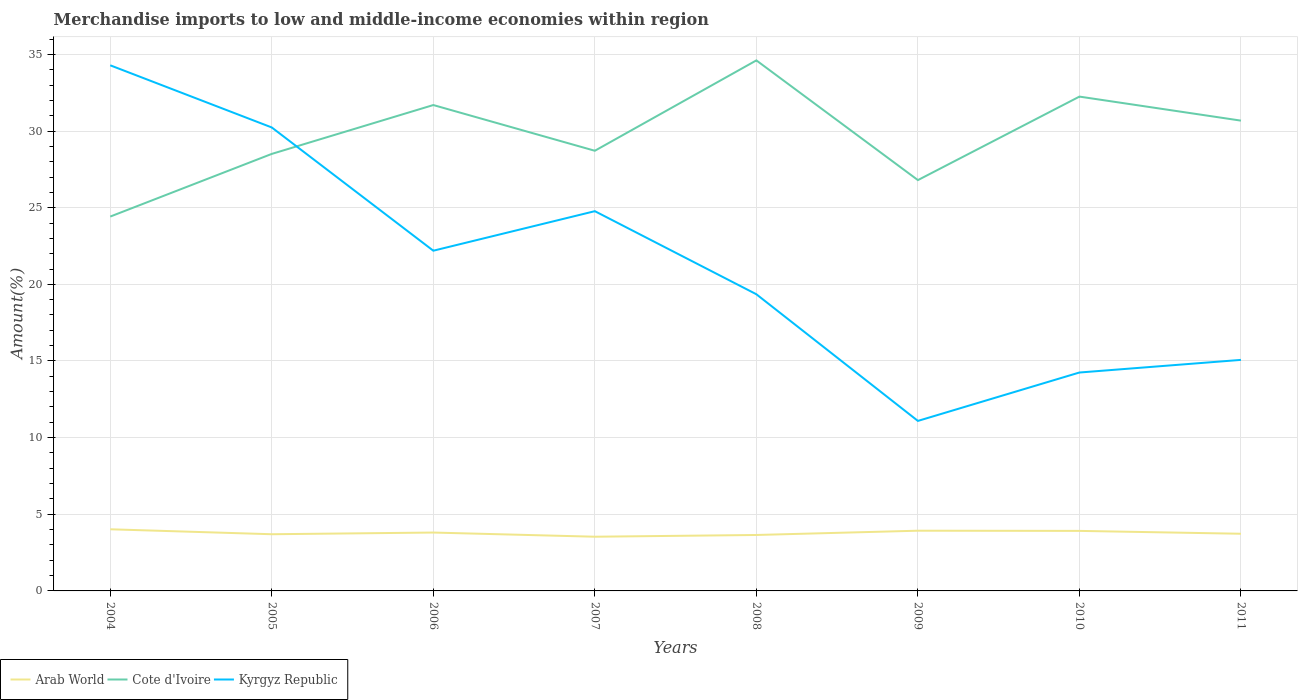Does the line corresponding to Cote d'Ivoire intersect with the line corresponding to Kyrgyz Republic?
Your answer should be very brief. Yes. Across all years, what is the maximum percentage of amount earned from merchandise imports in Arab World?
Provide a short and direct response. 3.54. In which year was the percentage of amount earned from merchandise imports in Arab World maximum?
Provide a succinct answer. 2007. What is the total percentage of amount earned from merchandise imports in Arab World in the graph?
Provide a succinct answer. 0.05. What is the difference between the highest and the second highest percentage of amount earned from merchandise imports in Arab World?
Make the answer very short. 0.49. What is the difference between the highest and the lowest percentage of amount earned from merchandise imports in Cote d'Ivoire?
Your answer should be very brief. 4. How many years are there in the graph?
Give a very brief answer. 8. What is the difference between two consecutive major ticks on the Y-axis?
Ensure brevity in your answer.  5. Are the values on the major ticks of Y-axis written in scientific E-notation?
Provide a succinct answer. No. Does the graph contain any zero values?
Make the answer very short. No. Where does the legend appear in the graph?
Your response must be concise. Bottom left. How many legend labels are there?
Provide a short and direct response. 3. How are the legend labels stacked?
Provide a succinct answer. Horizontal. What is the title of the graph?
Your response must be concise. Merchandise imports to low and middle-income economies within region. What is the label or title of the Y-axis?
Ensure brevity in your answer.  Amount(%). What is the Amount(%) of Arab World in 2004?
Provide a succinct answer. 4.02. What is the Amount(%) of Cote d'Ivoire in 2004?
Give a very brief answer. 24.42. What is the Amount(%) in Kyrgyz Republic in 2004?
Offer a terse response. 34.29. What is the Amount(%) of Arab World in 2005?
Make the answer very short. 3.7. What is the Amount(%) in Cote d'Ivoire in 2005?
Give a very brief answer. 28.51. What is the Amount(%) of Kyrgyz Republic in 2005?
Your response must be concise. 30.23. What is the Amount(%) in Arab World in 2006?
Your response must be concise. 3.81. What is the Amount(%) in Cote d'Ivoire in 2006?
Offer a very short reply. 31.7. What is the Amount(%) of Kyrgyz Republic in 2006?
Keep it short and to the point. 22.19. What is the Amount(%) of Arab World in 2007?
Offer a very short reply. 3.54. What is the Amount(%) of Cote d'Ivoire in 2007?
Your response must be concise. 28.71. What is the Amount(%) of Kyrgyz Republic in 2007?
Give a very brief answer. 24.77. What is the Amount(%) of Arab World in 2008?
Keep it short and to the point. 3.65. What is the Amount(%) of Cote d'Ivoire in 2008?
Keep it short and to the point. 34.61. What is the Amount(%) of Kyrgyz Republic in 2008?
Offer a terse response. 19.35. What is the Amount(%) of Arab World in 2009?
Offer a very short reply. 3.93. What is the Amount(%) of Cote d'Ivoire in 2009?
Offer a very short reply. 26.8. What is the Amount(%) in Kyrgyz Republic in 2009?
Ensure brevity in your answer.  11.09. What is the Amount(%) in Arab World in 2010?
Offer a terse response. 3.92. What is the Amount(%) in Cote d'Ivoire in 2010?
Keep it short and to the point. 32.25. What is the Amount(%) in Kyrgyz Republic in 2010?
Give a very brief answer. 14.25. What is the Amount(%) of Arab World in 2011?
Ensure brevity in your answer.  3.73. What is the Amount(%) of Cote d'Ivoire in 2011?
Provide a short and direct response. 30.68. What is the Amount(%) of Kyrgyz Republic in 2011?
Your answer should be compact. 15.07. Across all years, what is the maximum Amount(%) in Arab World?
Offer a very short reply. 4.02. Across all years, what is the maximum Amount(%) of Cote d'Ivoire?
Provide a succinct answer. 34.61. Across all years, what is the maximum Amount(%) of Kyrgyz Republic?
Offer a very short reply. 34.29. Across all years, what is the minimum Amount(%) in Arab World?
Make the answer very short. 3.54. Across all years, what is the minimum Amount(%) in Cote d'Ivoire?
Provide a short and direct response. 24.42. Across all years, what is the minimum Amount(%) in Kyrgyz Republic?
Offer a terse response. 11.09. What is the total Amount(%) of Arab World in the graph?
Your response must be concise. 30.29. What is the total Amount(%) of Cote d'Ivoire in the graph?
Offer a terse response. 237.68. What is the total Amount(%) of Kyrgyz Republic in the graph?
Offer a very short reply. 171.25. What is the difference between the Amount(%) of Arab World in 2004 and that in 2005?
Your answer should be very brief. 0.32. What is the difference between the Amount(%) in Cote d'Ivoire in 2004 and that in 2005?
Provide a succinct answer. -4.09. What is the difference between the Amount(%) in Kyrgyz Republic in 2004 and that in 2005?
Give a very brief answer. 4.05. What is the difference between the Amount(%) in Arab World in 2004 and that in 2006?
Provide a short and direct response. 0.21. What is the difference between the Amount(%) in Cote d'Ivoire in 2004 and that in 2006?
Provide a short and direct response. -7.28. What is the difference between the Amount(%) of Kyrgyz Republic in 2004 and that in 2006?
Your response must be concise. 12.09. What is the difference between the Amount(%) of Arab World in 2004 and that in 2007?
Ensure brevity in your answer.  0.49. What is the difference between the Amount(%) of Cote d'Ivoire in 2004 and that in 2007?
Offer a very short reply. -4.29. What is the difference between the Amount(%) of Kyrgyz Republic in 2004 and that in 2007?
Offer a terse response. 9.52. What is the difference between the Amount(%) in Arab World in 2004 and that in 2008?
Offer a terse response. 0.37. What is the difference between the Amount(%) of Cote d'Ivoire in 2004 and that in 2008?
Your answer should be very brief. -10.19. What is the difference between the Amount(%) in Kyrgyz Republic in 2004 and that in 2008?
Your answer should be compact. 14.94. What is the difference between the Amount(%) of Arab World in 2004 and that in 2009?
Provide a short and direct response. 0.09. What is the difference between the Amount(%) in Cote d'Ivoire in 2004 and that in 2009?
Offer a terse response. -2.38. What is the difference between the Amount(%) in Kyrgyz Republic in 2004 and that in 2009?
Give a very brief answer. 23.2. What is the difference between the Amount(%) in Arab World in 2004 and that in 2010?
Make the answer very short. 0.1. What is the difference between the Amount(%) in Cote d'Ivoire in 2004 and that in 2010?
Your response must be concise. -7.83. What is the difference between the Amount(%) in Kyrgyz Republic in 2004 and that in 2010?
Your response must be concise. 20.04. What is the difference between the Amount(%) of Arab World in 2004 and that in 2011?
Ensure brevity in your answer.  0.29. What is the difference between the Amount(%) of Cote d'Ivoire in 2004 and that in 2011?
Make the answer very short. -6.26. What is the difference between the Amount(%) in Kyrgyz Republic in 2004 and that in 2011?
Your answer should be compact. 19.22. What is the difference between the Amount(%) of Arab World in 2005 and that in 2006?
Offer a terse response. -0.11. What is the difference between the Amount(%) in Cote d'Ivoire in 2005 and that in 2006?
Your answer should be compact. -3.19. What is the difference between the Amount(%) of Kyrgyz Republic in 2005 and that in 2006?
Make the answer very short. 8.04. What is the difference between the Amount(%) in Arab World in 2005 and that in 2007?
Give a very brief answer. 0.16. What is the difference between the Amount(%) of Cote d'Ivoire in 2005 and that in 2007?
Give a very brief answer. -0.21. What is the difference between the Amount(%) of Kyrgyz Republic in 2005 and that in 2007?
Ensure brevity in your answer.  5.46. What is the difference between the Amount(%) in Arab World in 2005 and that in 2008?
Your response must be concise. 0.05. What is the difference between the Amount(%) of Cote d'Ivoire in 2005 and that in 2008?
Give a very brief answer. -6.1. What is the difference between the Amount(%) in Kyrgyz Republic in 2005 and that in 2008?
Offer a very short reply. 10.88. What is the difference between the Amount(%) of Arab World in 2005 and that in 2009?
Provide a short and direct response. -0.23. What is the difference between the Amount(%) in Cote d'Ivoire in 2005 and that in 2009?
Offer a terse response. 1.71. What is the difference between the Amount(%) in Kyrgyz Republic in 2005 and that in 2009?
Provide a short and direct response. 19.14. What is the difference between the Amount(%) in Arab World in 2005 and that in 2010?
Keep it short and to the point. -0.22. What is the difference between the Amount(%) of Cote d'Ivoire in 2005 and that in 2010?
Your response must be concise. -3.74. What is the difference between the Amount(%) in Kyrgyz Republic in 2005 and that in 2010?
Your answer should be very brief. 15.99. What is the difference between the Amount(%) in Arab World in 2005 and that in 2011?
Your answer should be compact. -0.03. What is the difference between the Amount(%) of Cote d'Ivoire in 2005 and that in 2011?
Offer a terse response. -2.17. What is the difference between the Amount(%) of Kyrgyz Republic in 2005 and that in 2011?
Your answer should be very brief. 15.16. What is the difference between the Amount(%) in Arab World in 2006 and that in 2007?
Provide a short and direct response. 0.27. What is the difference between the Amount(%) in Cote d'Ivoire in 2006 and that in 2007?
Your response must be concise. 2.98. What is the difference between the Amount(%) of Kyrgyz Republic in 2006 and that in 2007?
Offer a terse response. -2.58. What is the difference between the Amount(%) in Arab World in 2006 and that in 2008?
Your answer should be very brief. 0.16. What is the difference between the Amount(%) in Cote d'Ivoire in 2006 and that in 2008?
Keep it short and to the point. -2.91. What is the difference between the Amount(%) in Kyrgyz Republic in 2006 and that in 2008?
Offer a terse response. 2.84. What is the difference between the Amount(%) in Arab World in 2006 and that in 2009?
Give a very brief answer. -0.12. What is the difference between the Amount(%) in Cote d'Ivoire in 2006 and that in 2009?
Keep it short and to the point. 4.9. What is the difference between the Amount(%) of Kyrgyz Republic in 2006 and that in 2009?
Provide a succinct answer. 11.1. What is the difference between the Amount(%) of Arab World in 2006 and that in 2010?
Your response must be concise. -0.11. What is the difference between the Amount(%) of Cote d'Ivoire in 2006 and that in 2010?
Offer a terse response. -0.55. What is the difference between the Amount(%) in Kyrgyz Republic in 2006 and that in 2010?
Your answer should be very brief. 7.95. What is the difference between the Amount(%) of Arab World in 2006 and that in 2011?
Provide a short and direct response. 0.08. What is the difference between the Amount(%) in Cote d'Ivoire in 2006 and that in 2011?
Make the answer very short. 1.02. What is the difference between the Amount(%) of Kyrgyz Republic in 2006 and that in 2011?
Offer a terse response. 7.12. What is the difference between the Amount(%) of Arab World in 2007 and that in 2008?
Give a very brief answer. -0.11. What is the difference between the Amount(%) of Cote d'Ivoire in 2007 and that in 2008?
Offer a very short reply. -5.89. What is the difference between the Amount(%) of Kyrgyz Republic in 2007 and that in 2008?
Provide a short and direct response. 5.42. What is the difference between the Amount(%) of Arab World in 2007 and that in 2009?
Give a very brief answer. -0.39. What is the difference between the Amount(%) of Cote d'Ivoire in 2007 and that in 2009?
Your answer should be compact. 1.91. What is the difference between the Amount(%) in Kyrgyz Republic in 2007 and that in 2009?
Offer a terse response. 13.68. What is the difference between the Amount(%) in Arab World in 2007 and that in 2010?
Your answer should be very brief. -0.38. What is the difference between the Amount(%) of Cote d'Ivoire in 2007 and that in 2010?
Make the answer very short. -3.53. What is the difference between the Amount(%) in Kyrgyz Republic in 2007 and that in 2010?
Your answer should be very brief. 10.53. What is the difference between the Amount(%) of Arab World in 2007 and that in 2011?
Keep it short and to the point. -0.19. What is the difference between the Amount(%) of Cote d'Ivoire in 2007 and that in 2011?
Provide a short and direct response. -1.97. What is the difference between the Amount(%) in Kyrgyz Republic in 2007 and that in 2011?
Your answer should be compact. 9.7. What is the difference between the Amount(%) in Arab World in 2008 and that in 2009?
Your response must be concise. -0.28. What is the difference between the Amount(%) of Cote d'Ivoire in 2008 and that in 2009?
Provide a short and direct response. 7.81. What is the difference between the Amount(%) of Kyrgyz Republic in 2008 and that in 2009?
Keep it short and to the point. 8.26. What is the difference between the Amount(%) of Arab World in 2008 and that in 2010?
Ensure brevity in your answer.  -0.27. What is the difference between the Amount(%) in Cote d'Ivoire in 2008 and that in 2010?
Give a very brief answer. 2.36. What is the difference between the Amount(%) in Kyrgyz Republic in 2008 and that in 2010?
Keep it short and to the point. 5.11. What is the difference between the Amount(%) in Arab World in 2008 and that in 2011?
Your answer should be very brief. -0.08. What is the difference between the Amount(%) of Cote d'Ivoire in 2008 and that in 2011?
Ensure brevity in your answer.  3.93. What is the difference between the Amount(%) in Kyrgyz Republic in 2008 and that in 2011?
Provide a short and direct response. 4.28. What is the difference between the Amount(%) of Arab World in 2009 and that in 2010?
Keep it short and to the point. 0.01. What is the difference between the Amount(%) of Cote d'Ivoire in 2009 and that in 2010?
Give a very brief answer. -5.45. What is the difference between the Amount(%) in Kyrgyz Republic in 2009 and that in 2010?
Your response must be concise. -3.16. What is the difference between the Amount(%) of Arab World in 2009 and that in 2011?
Ensure brevity in your answer.  0.2. What is the difference between the Amount(%) of Cote d'Ivoire in 2009 and that in 2011?
Ensure brevity in your answer.  -3.88. What is the difference between the Amount(%) in Kyrgyz Republic in 2009 and that in 2011?
Provide a succinct answer. -3.98. What is the difference between the Amount(%) of Arab World in 2010 and that in 2011?
Your response must be concise. 0.19. What is the difference between the Amount(%) of Cote d'Ivoire in 2010 and that in 2011?
Keep it short and to the point. 1.57. What is the difference between the Amount(%) of Kyrgyz Republic in 2010 and that in 2011?
Provide a short and direct response. -0.82. What is the difference between the Amount(%) in Arab World in 2004 and the Amount(%) in Cote d'Ivoire in 2005?
Offer a terse response. -24.49. What is the difference between the Amount(%) in Arab World in 2004 and the Amount(%) in Kyrgyz Republic in 2005?
Your response must be concise. -26.21. What is the difference between the Amount(%) of Cote d'Ivoire in 2004 and the Amount(%) of Kyrgyz Republic in 2005?
Provide a succinct answer. -5.81. What is the difference between the Amount(%) of Arab World in 2004 and the Amount(%) of Cote d'Ivoire in 2006?
Provide a succinct answer. -27.68. What is the difference between the Amount(%) of Arab World in 2004 and the Amount(%) of Kyrgyz Republic in 2006?
Your answer should be very brief. -18.17. What is the difference between the Amount(%) of Cote d'Ivoire in 2004 and the Amount(%) of Kyrgyz Republic in 2006?
Make the answer very short. 2.23. What is the difference between the Amount(%) in Arab World in 2004 and the Amount(%) in Cote d'Ivoire in 2007?
Give a very brief answer. -24.69. What is the difference between the Amount(%) in Arab World in 2004 and the Amount(%) in Kyrgyz Republic in 2007?
Give a very brief answer. -20.75. What is the difference between the Amount(%) in Cote d'Ivoire in 2004 and the Amount(%) in Kyrgyz Republic in 2007?
Keep it short and to the point. -0.35. What is the difference between the Amount(%) of Arab World in 2004 and the Amount(%) of Cote d'Ivoire in 2008?
Keep it short and to the point. -30.59. What is the difference between the Amount(%) of Arab World in 2004 and the Amount(%) of Kyrgyz Republic in 2008?
Your answer should be very brief. -15.33. What is the difference between the Amount(%) of Cote d'Ivoire in 2004 and the Amount(%) of Kyrgyz Republic in 2008?
Offer a terse response. 5.07. What is the difference between the Amount(%) of Arab World in 2004 and the Amount(%) of Cote d'Ivoire in 2009?
Ensure brevity in your answer.  -22.78. What is the difference between the Amount(%) in Arab World in 2004 and the Amount(%) in Kyrgyz Republic in 2009?
Provide a succinct answer. -7.07. What is the difference between the Amount(%) of Cote d'Ivoire in 2004 and the Amount(%) of Kyrgyz Republic in 2009?
Offer a terse response. 13.33. What is the difference between the Amount(%) of Arab World in 2004 and the Amount(%) of Cote d'Ivoire in 2010?
Offer a terse response. -28.23. What is the difference between the Amount(%) of Arab World in 2004 and the Amount(%) of Kyrgyz Republic in 2010?
Offer a very short reply. -10.23. What is the difference between the Amount(%) of Cote d'Ivoire in 2004 and the Amount(%) of Kyrgyz Republic in 2010?
Offer a very short reply. 10.17. What is the difference between the Amount(%) of Arab World in 2004 and the Amount(%) of Cote d'Ivoire in 2011?
Your response must be concise. -26.66. What is the difference between the Amount(%) in Arab World in 2004 and the Amount(%) in Kyrgyz Republic in 2011?
Offer a terse response. -11.05. What is the difference between the Amount(%) in Cote d'Ivoire in 2004 and the Amount(%) in Kyrgyz Republic in 2011?
Provide a succinct answer. 9.35. What is the difference between the Amount(%) of Arab World in 2005 and the Amount(%) of Cote d'Ivoire in 2006?
Your answer should be very brief. -28. What is the difference between the Amount(%) of Arab World in 2005 and the Amount(%) of Kyrgyz Republic in 2006?
Provide a succinct answer. -18.5. What is the difference between the Amount(%) in Cote d'Ivoire in 2005 and the Amount(%) in Kyrgyz Republic in 2006?
Provide a succinct answer. 6.31. What is the difference between the Amount(%) in Arab World in 2005 and the Amount(%) in Cote d'Ivoire in 2007?
Offer a very short reply. -25.02. What is the difference between the Amount(%) of Arab World in 2005 and the Amount(%) of Kyrgyz Republic in 2007?
Give a very brief answer. -21.08. What is the difference between the Amount(%) in Cote d'Ivoire in 2005 and the Amount(%) in Kyrgyz Republic in 2007?
Keep it short and to the point. 3.74. What is the difference between the Amount(%) of Arab World in 2005 and the Amount(%) of Cote d'Ivoire in 2008?
Offer a very short reply. -30.91. What is the difference between the Amount(%) of Arab World in 2005 and the Amount(%) of Kyrgyz Republic in 2008?
Offer a very short reply. -15.66. What is the difference between the Amount(%) of Cote d'Ivoire in 2005 and the Amount(%) of Kyrgyz Republic in 2008?
Provide a succinct answer. 9.16. What is the difference between the Amount(%) in Arab World in 2005 and the Amount(%) in Cote d'Ivoire in 2009?
Make the answer very short. -23.1. What is the difference between the Amount(%) in Arab World in 2005 and the Amount(%) in Kyrgyz Republic in 2009?
Offer a very short reply. -7.39. What is the difference between the Amount(%) of Cote d'Ivoire in 2005 and the Amount(%) of Kyrgyz Republic in 2009?
Ensure brevity in your answer.  17.42. What is the difference between the Amount(%) in Arab World in 2005 and the Amount(%) in Cote d'Ivoire in 2010?
Offer a terse response. -28.55. What is the difference between the Amount(%) in Arab World in 2005 and the Amount(%) in Kyrgyz Republic in 2010?
Offer a very short reply. -10.55. What is the difference between the Amount(%) in Cote d'Ivoire in 2005 and the Amount(%) in Kyrgyz Republic in 2010?
Give a very brief answer. 14.26. What is the difference between the Amount(%) of Arab World in 2005 and the Amount(%) of Cote d'Ivoire in 2011?
Your answer should be very brief. -26.98. What is the difference between the Amount(%) in Arab World in 2005 and the Amount(%) in Kyrgyz Republic in 2011?
Keep it short and to the point. -11.37. What is the difference between the Amount(%) in Cote d'Ivoire in 2005 and the Amount(%) in Kyrgyz Republic in 2011?
Give a very brief answer. 13.44. What is the difference between the Amount(%) of Arab World in 2006 and the Amount(%) of Cote d'Ivoire in 2007?
Offer a very short reply. -24.91. What is the difference between the Amount(%) in Arab World in 2006 and the Amount(%) in Kyrgyz Republic in 2007?
Your answer should be very brief. -20.97. What is the difference between the Amount(%) in Cote d'Ivoire in 2006 and the Amount(%) in Kyrgyz Republic in 2007?
Ensure brevity in your answer.  6.92. What is the difference between the Amount(%) in Arab World in 2006 and the Amount(%) in Cote d'Ivoire in 2008?
Your answer should be compact. -30.8. What is the difference between the Amount(%) of Arab World in 2006 and the Amount(%) of Kyrgyz Republic in 2008?
Your response must be concise. -15.55. What is the difference between the Amount(%) of Cote d'Ivoire in 2006 and the Amount(%) of Kyrgyz Republic in 2008?
Your answer should be very brief. 12.34. What is the difference between the Amount(%) of Arab World in 2006 and the Amount(%) of Cote d'Ivoire in 2009?
Offer a very short reply. -22.99. What is the difference between the Amount(%) of Arab World in 2006 and the Amount(%) of Kyrgyz Republic in 2009?
Offer a very short reply. -7.28. What is the difference between the Amount(%) in Cote d'Ivoire in 2006 and the Amount(%) in Kyrgyz Republic in 2009?
Your answer should be compact. 20.61. What is the difference between the Amount(%) of Arab World in 2006 and the Amount(%) of Cote d'Ivoire in 2010?
Provide a succinct answer. -28.44. What is the difference between the Amount(%) of Arab World in 2006 and the Amount(%) of Kyrgyz Republic in 2010?
Offer a very short reply. -10.44. What is the difference between the Amount(%) of Cote d'Ivoire in 2006 and the Amount(%) of Kyrgyz Republic in 2010?
Offer a very short reply. 17.45. What is the difference between the Amount(%) of Arab World in 2006 and the Amount(%) of Cote d'Ivoire in 2011?
Offer a very short reply. -26.87. What is the difference between the Amount(%) of Arab World in 2006 and the Amount(%) of Kyrgyz Republic in 2011?
Your answer should be very brief. -11.26. What is the difference between the Amount(%) in Cote d'Ivoire in 2006 and the Amount(%) in Kyrgyz Republic in 2011?
Ensure brevity in your answer.  16.62. What is the difference between the Amount(%) of Arab World in 2007 and the Amount(%) of Cote d'Ivoire in 2008?
Offer a terse response. -31.07. What is the difference between the Amount(%) of Arab World in 2007 and the Amount(%) of Kyrgyz Republic in 2008?
Your answer should be compact. -15.82. What is the difference between the Amount(%) in Cote d'Ivoire in 2007 and the Amount(%) in Kyrgyz Republic in 2008?
Keep it short and to the point. 9.36. What is the difference between the Amount(%) of Arab World in 2007 and the Amount(%) of Cote d'Ivoire in 2009?
Ensure brevity in your answer.  -23.26. What is the difference between the Amount(%) of Arab World in 2007 and the Amount(%) of Kyrgyz Republic in 2009?
Provide a short and direct response. -7.55. What is the difference between the Amount(%) of Cote d'Ivoire in 2007 and the Amount(%) of Kyrgyz Republic in 2009?
Give a very brief answer. 17.62. What is the difference between the Amount(%) in Arab World in 2007 and the Amount(%) in Cote d'Ivoire in 2010?
Provide a short and direct response. -28.71. What is the difference between the Amount(%) of Arab World in 2007 and the Amount(%) of Kyrgyz Republic in 2010?
Ensure brevity in your answer.  -10.71. What is the difference between the Amount(%) of Cote d'Ivoire in 2007 and the Amount(%) of Kyrgyz Republic in 2010?
Ensure brevity in your answer.  14.47. What is the difference between the Amount(%) of Arab World in 2007 and the Amount(%) of Cote d'Ivoire in 2011?
Your answer should be very brief. -27.14. What is the difference between the Amount(%) of Arab World in 2007 and the Amount(%) of Kyrgyz Republic in 2011?
Offer a terse response. -11.54. What is the difference between the Amount(%) of Cote d'Ivoire in 2007 and the Amount(%) of Kyrgyz Republic in 2011?
Your answer should be compact. 13.64. What is the difference between the Amount(%) in Arab World in 2008 and the Amount(%) in Cote d'Ivoire in 2009?
Make the answer very short. -23.15. What is the difference between the Amount(%) of Arab World in 2008 and the Amount(%) of Kyrgyz Republic in 2009?
Your answer should be compact. -7.44. What is the difference between the Amount(%) in Cote d'Ivoire in 2008 and the Amount(%) in Kyrgyz Republic in 2009?
Give a very brief answer. 23.52. What is the difference between the Amount(%) in Arab World in 2008 and the Amount(%) in Cote d'Ivoire in 2010?
Provide a short and direct response. -28.6. What is the difference between the Amount(%) of Arab World in 2008 and the Amount(%) of Kyrgyz Republic in 2010?
Provide a short and direct response. -10.6. What is the difference between the Amount(%) of Cote d'Ivoire in 2008 and the Amount(%) of Kyrgyz Republic in 2010?
Your response must be concise. 20.36. What is the difference between the Amount(%) of Arab World in 2008 and the Amount(%) of Cote d'Ivoire in 2011?
Offer a very short reply. -27.03. What is the difference between the Amount(%) of Arab World in 2008 and the Amount(%) of Kyrgyz Republic in 2011?
Your answer should be compact. -11.42. What is the difference between the Amount(%) of Cote d'Ivoire in 2008 and the Amount(%) of Kyrgyz Republic in 2011?
Offer a very short reply. 19.54. What is the difference between the Amount(%) in Arab World in 2009 and the Amount(%) in Cote d'Ivoire in 2010?
Your response must be concise. -28.32. What is the difference between the Amount(%) of Arab World in 2009 and the Amount(%) of Kyrgyz Republic in 2010?
Ensure brevity in your answer.  -10.32. What is the difference between the Amount(%) in Cote d'Ivoire in 2009 and the Amount(%) in Kyrgyz Republic in 2010?
Your response must be concise. 12.55. What is the difference between the Amount(%) of Arab World in 2009 and the Amount(%) of Cote d'Ivoire in 2011?
Ensure brevity in your answer.  -26.75. What is the difference between the Amount(%) of Arab World in 2009 and the Amount(%) of Kyrgyz Republic in 2011?
Offer a terse response. -11.14. What is the difference between the Amount(%) in Cote d'Ivoire in 2009 and the Amount(%) in Kyrgyz Republic in 2011?
Make the answer very short. 11.73. What is the difference between the Amount(%) of Arab World in 2010 and the Amount(%) of Cote d'Ivoire in 2011?
Provide a short and direct response. -26.76. What is the difference between the Amount(%) in Arab World in 2010 and the Amount(%) in Kyrgyz Republic in 2011?
Ensure brevity in your answer.  -11.16. What is the difference between the Amount(%) in Cote d'Ivoire in 2010 and the Amount(%) in Kyrgyz Republic in 2011?
Give a very brief answer. 17.18. What is the average Amount(%) in Arab World per year?
Keep it short and to the point. 3.79. What is the average Amount(%) of Cote d'Ivoire per year?
Offer a terse response. 29.71. What is the average Amount(%) in Kyrgyz Republic per year?
Provide a succinct answer. 21.41. In the year 2004, what is the difference between the Amount(%) in Arab World and Amount(%) in Cote d'Ivoire?
Your answer should be very brief. -20.4. In the year 2004, what is the difference between the Amount(%) of Arab World and Amount(%) of Kyrgyz Republic?
Offer a very short reply. -30.27. In the year 2004, what is the difference between the Amount(%) in Cote d'Ivoire and Amount(%) in Kyrgyz Republic?
Offer a terse response. -9.87. In the year 2005, what is the difference between the Amount(%) of Arab World and Amount(%) of Cote d'Ivoire?
Make the answer very short. -24.81. In the year 2005, what is the difference between the Amount(%) in Arab World and Amount(%) in Kyrgyz Republic?
Your answer should be very brief. -26.54. In the year 2005, what is the difference between the Amount(%) of Cote d'Ivoire and Amount(%) of Kyrgyz Republic?
Provide a succinct answer. -1.72. In the year 2006, what is the difference between the Amount(%) in Arab World and Amount(%) in Cote d'Ivoire?
Make the answer very short. -27.89. In the year 2006, what is the difference between the Amount(%) in Arab World and Amount(%) in Kyrgyz Republic?
Your response must be concise. -18.39. In the year 2006, what is the difference between the Amount(%) of Cote d'Ivoire and Amount(%) of Kyrgyz Republic?
Provide a succinct answer. 9.5. In the year 2007, what is the difference between the Amount(%) of Arab World and Amount(%) of Cote d'Ivoire?
Provide a short and direct response. -25.18. In the year 2007, what is the difference between the Amount(%) of Arab World and Amount(%) of Kyrgyz Republic?
Make the answer very short. -21.24. In the year 2007, what is the difference between the Amount(%) in Cote d'Ivoire and Amount(%) in Kyrgyz Republic?
Offer a very short reply. 3.94. In the year 2008, what is the difference between the Amount(%) in Arab World and Amount(%) in Cote d'Ivoire?
Ensure brevity in your answer.  -30.96. In the year 2008, what is the difference between the Amount(%) of Arab World and Amount(%) of Kyrgyz Republic?
Make the answer very short. -15.7. In the year 2008, what is the difference between the Amount(%) in Cote d'Ivoire and Amount(%) in Kyrgyz Republic?
Your answer should be compact. 15.26. In the year 2009, what is the difference between the Amount(%) in Arab World and Amount(%) in Cote d'Ivoire?
Your answer should be very brief. -22.87. In the year 2009, what is the difference between the Amount(%) of Arab World and Amount(%) of Kyrgyz Republic?
Ensure brevity in your answer.  -7.16. In the year 2009, what is the difference between the Amount(%) of Cote d'Ivoire and Amount(%) of Kyrgyz Republic?
Provide a short and direct response. 15.71. In the year 2010, what is the difference between the Amount(%) in Arab World and Amount(%) in Cote d'Ivoire?
Provide a short and direct response. -28.33. In the year 2010, what is the difference between the Amount(%) in Arab World and Amount(%) in Kyrgyz Republic?
Give a very brief answer. -10.33. In the year 2010, what is the difference between the Amount(%) in Cote d'Ivoire and Amount(%) in Kyrgyz Republic?
Give a very brief answer. 18. In the year 2011, what is the difference between the Amount(%) of Arab World and Amount(%) of Cote d'Ivoire?
Make the answer very short. -26.95. In the year 2011, what is the difference between the Amount(%) in Arab World and Amount(%) in Kyrgyz Republic?
Provide a succinct answer. -11.34. In the year 2011, what is the difference between the Amount(%) in Cote d'Ivoire and Amount(%) in Kyrgyz Republic?
Provide a succinct answer. 15.61. What is the ratio of the Amount(%) of Arab World in 2004 to that in 2005?
Offer a very short reply. 1.09. What is the ratio of the Amount(%) in Cote d'Ivoire in 2004 to that in 2005?
Ensure brevity in your answer.  0.86. What is the ratio of the Amount(%) of Kyrgyz Republic in 2004 to that in 2005?
Make the answer very short. 1.13. What is the ratio of the Amount(%) in Arab World in 2004 to that in 2006?
Ensure brevity in your answer.  1.06. What is the ratio of the Amount(%) in Cote d'Ivoire in 2004 to that in 2006?
Provide a succinct answer. 0.77. What is the ratio of the Amount(%) in Kyrgyz Republic in 2004 to that in 2006?
Your answer should be very brief. 1.54. What is the ratio of the Amount(%) of Arab World in 2004 to that in 2007?
Your answer should be compact. 1.14. What is the ratio of the Amount(%) in Cote d'Ivoire in 2004 to that in 2007?
Provide a succinct answer. 0.85. What is the ratio of the Amount(%) of Kyrgyz Republic in 2004 to that in 2007?
Provide a short and direct response. 1.38. What is the ratio of the Amount(%) of Arab World in 2004 to that in 2008?
Your response must be concise. 1.1. What is the ratio of the Amount(%) in Cote d'Ivoire in 2004 to that in 2008?
Offer a very short reply. 0.71. What is the ratio of the Amount(%) of Kyrgyz Republic in 2004 to that in 2008?
Ensure brevity in your answer.  1.77. What is the ratio of the Amount(%) in Arab World in 2004 to that in 2009?
Make the answer very short. 1.02. What is the ratio of the Amount(%) of Cote d'Ivoire in 2004 to that in 2009?
Give a very brief answer. 0.91. What is the ratio of the Amount(%) of Kyrgyz Republic in 2004 to that in 2009?
Ensure brevity in your answer.  3.09. What is the ratio of the Amount(%) in Arab World in 2004 to that in 2010?
Keep it short and to the point. 1.03. What is the ratio of the Amount(%) in Cote d'Ivoire in 2004 to that in 2010?
Make the answer very short. 0.76. What is the ratio of the Amount(%) of Kyrgyz Republic in 2004 to that in 2010?
Provide a short and direct response. 2.41. What is the ratio of the Amount(%) in Arab World in 2004 to that in 2011?
Make the answer very short. 1.08. What is the ratio of the Amount(%) in Cote d'Ivoire in 2004 to that in 2011?
Provide a succinct answer. 0.8. What is the ratio of the Amount(%) of Kyrgyz Republic in 2004 to that in 2011?
Provide a short and direct response. 2.27. What is the ratio of the Amount(%) in Arab World in 2005 to that in 2006?
Make the answer very short. 0.97. What is the ratio of the Amount(%) in Cote d'Ivoire in 2005 to that in 2006?
Provide a short and direct response. 0.9. What is the ratio of the Amount(%) of Kyrgyz Republic in 2005 to that in 2006?
Offer a terse response. 1.36. What is the ratio of the Amount(%) of Arab World in 2005 to that in 2007?
Make the answer very short. 1.05. What is the ratio of the Amount(%) in Kyrgyz Republic in 2005 to that in 2007?
Your response must be concise. 1.22. What is the ratio of the Amount(%) of Arab World in 2005 to that in 2008?
Ensure brevity in your answer.  1.01. What is the ratio of the Amount(%) of Cote d'Ivoire in 2005 to that in 2008?
Make the answer very short. 0.82. What is the ratio of the Amount(%) in Kyrgyz Republic in 2005 to that in 2008?
Offer a terse response. 1.56. What is the ratio of the Amount(%) in Arab World in 2005 to that in 2009?
Give a very brief answer. 0.94. What is the ratio of the Amount(%) in Cote d'Ivoire in 2005 to that in 2009?
Provide a short and direct response. 1.06. What is the ratio of the Amount(%) in Kyrgyz Republic in 2005 to that in 2009?
Ensure brevity in your answer.  2.73. What is the ratio of the Amount(%) of Arab World in 2005 to that in 2010?
Your answer should be compact. 0.94. What is the ratio of the Amount(%) of Cote d'Ivoire in 2005 to that in 2010?
Keep it short and to the point. 0.88. What is the ratio of the Amount(%) of Kyrgyz Republic in 2005 to that in 2010?
Your response must be concise. 2.12. What is the ratio of the Amount(%) of Arab World in 2005 to that in 2011?
Provide a short and direct response. 0.99. What is the ratio of the Amount(%) of Cote d'Ivoire in 2005 to that in 2011?
Provide a short and direct response. 0.93. What is the ratio of the Amount(%) in Kyrgyz Republic in 2005 to that in 2011?
Your answer should be very brief. 2.01. What is the ratio of the Amount(%) of Arab World in 2006 to that in 2007?
Provide a short and direct response. 1.08. What is the ratio of the Amount(%) in Cote d'Ivoire in 2006 to that in 2007?
Make the answer very short. 1.1. What is the ratio of the Amount(%) of Kyrgyz Republic in 2006 to that in 2007?
Offer a very short reply. 0.9. What is the ratio of the Amount(%) in Arab World in 2006 to that in 2008?
Your answer should be compact. 1.04. What is the ratio of the Amount(%) of Cote d'Ivoire in 2006 to that in 2008?
Make the answer very short. 0.92. What is the ratio of the Amount(%) in Kyrgyz Republic in 2006 to that in 2008?
Offer a very short reply. 1.15. What is the ratio of the Amount(%) of Arab World in 2006 to that in 2009?
Provide a succinct answer. 0.97. What is the ratio of the Amount(%) of Cote d'Ivoire in 2006 to that in 2009?
Your answer should be very brief. 1.18. What is the ratio of the Amount(%) in Kyrgyz Republic in 2006 to that in 2009?
Give a very brief answer. 2. What is the ratio of the Amount(%) of Arab World in 2006 to that in 2010?
Keep it short and to the point. 0.97. What is the ratio of the Amount(%) of Cote d'Ivoire in 2006 to that in 2010?
Provide a succinct answer. 0.98. What is the ratio of the Amount(%) of Kyrgyz Republic in 2006 to that in 2010?
Your answer should be compact. 1.56. What is the ratio of the Amount(%) in Arab World in 2006 to that in 2011?
Make the answer very short. 1.02. What is the ratio of the Amount(%) of Cote d'Ivoire in 2006 to that in 2011?
Offer a very short reply. 1.03. What is the ratio of the Amount(%) in Kyrgyz Republic in 2006 to that in 2011?
Your answer should be very brief. 1.47. What is the ratio of the Amount(%) in Arab World in 2007 to that in 2008?
Make the answer very short. 0.97. What is the ratio of the Amount(%) of Cote d'Ivoire in 2007 to that in 2008?
Offer a very short reply. 0.83. What is the ratio of the Amount(%) in Kyrgyz Republic in 2007 to that in 2008?
Make the answer very short. 1.28. What is the ratio of the Amount(%) in Arab World in 2007 to that in 2009?
Provide a succinct answer. 0.9. What is the ratio of the Amount(%) in Cote d'Ivoire in 2007 to that in 2009?
Make the answer very short. 1.07. What is the ratio of the Amount(%) in Kyrgyz Republic in 2007 to that in 2009?
Ensure brevity in your answer.  2.23. What is the ratio of the Amount(%) in Arab World in 2007 to that in 2010?
Ensure brevity in your answer.  0.9. What is the ratio of the Amount(%) in Cote d'Ivoire in 2007 to that in 2010?
Ensure brevity in your answer.  0.89. What is the ratio of the Amount(%) of Kyrgyz Republic in 2007 to that in 2010?
Provide a succinct answer. 1.74. What is the ratio of the Amount(%) in Arab World in 2007 to that in 2011?
Give a very brief answer. 0.95. What is the ratio of the Amount(%) in Cote d'Ivoire in 2007 to that in 2011?
Your answer should be compact. 0.94. What is the ratio of the Amount(%) in Kyrgyz Republic in 2007 to that in 2011?
Your answer should be compact. 1.64. What is the ratio of the Amount(%) of Arab World in 2008 to that in 2009?
Give a very brief answer. 0.93. What is the ratio of the Amount(%) of Cote d'Ivoire in 2008 to that in 2009?
Give a very brief answer. 1.29. What is the ratio of the Amount(%) in Kyrgyz Republic in 2008 to that in 2009?
Make the answer very short. 1.75. What is the ratio of the Amount(%) of Arab World in 2008 to that in 2010?
Ensure brevity in your answer.  0.93. What is the ratio of the Amount(%) in Cote d'Ivoire in 2008 to that in 2010?
Offer a very short reply. 1.07. What is the ratio of the Amount(%) in Kyrgyz Republic in 2008 to that in 2010?
Give a very brief answer. 1.36. What is the ratio of the Amount(%) in Arab World in 2008 to that in 2011?
Your answer should be very brief. 0.98. What is the ratio of the Amount(%) of Cote d'Ivoire in 2008 to that in 2011?
Your response must be concise. 1.13. What is the ratio of the Amount(%) in Kyrgyz Republic in 2008 to that in 2011?
Ensure brevity in your answer.  1.28. What is the ratio of the Amount(%) in Arab World in 2009 to that in 2010?
Provide a succinct answer. 1. What is the ratio of the Amount(%) of Cote d'Ivoire in 2009 to that in 2010?
Your answer should be very brief. 0.83. What is the ratio of the Amount(%) in Kyrgyz Republic in 2009 to that in 2010?
Your answer should be compact. 0.78. What is the ratio of the Amount(%) in Arab World in 2009 to that in 2011?
Your response must be concise. 1.05. What is the ratio of the Amount(%) of Cote d'Ivoire in 2009 to that in 2011?
Provide a succinct answer. 0.87. What is the ratio of the Amount(%) of Kyrgyz Republic in 2009 to that in 2011?
Offer a terse response. 0.74. What is the ratio of the Amount(%) of Cote d'Ivoire in 2010 to that in 2011?
Provide a short and direct response. 1.05. What is the ratio of the Amount(%) of Kyrgyz Republic in 2010 to that in 2011?
Provide a succinct answer. 0.95. What is the difference between the highest and the second highest Amount(%) in Arab World?
Offer a very short reply. 0.09. What is the difference between the highest and the second highest Amount(%) in Cote d'Ivoire?
Your answer should be compact. 2.36. What is the difference between the highest and the second highest Amount(%) of Kyrgyz Republic?
Your answer should be very brief. 4.05. What is the difference between the highest and the lowest Amount(%) of Arab World?
Your answer should be compact. 0.49. What is the difference between the highest and the lowest Amount(%) in Cote d'Ivoire?
Provide a short and direct response. 10.19. What is the difference between the highest and the lowest Amount(%) in Kyrgyz Republic?
Make the answer very short. 23.2. 